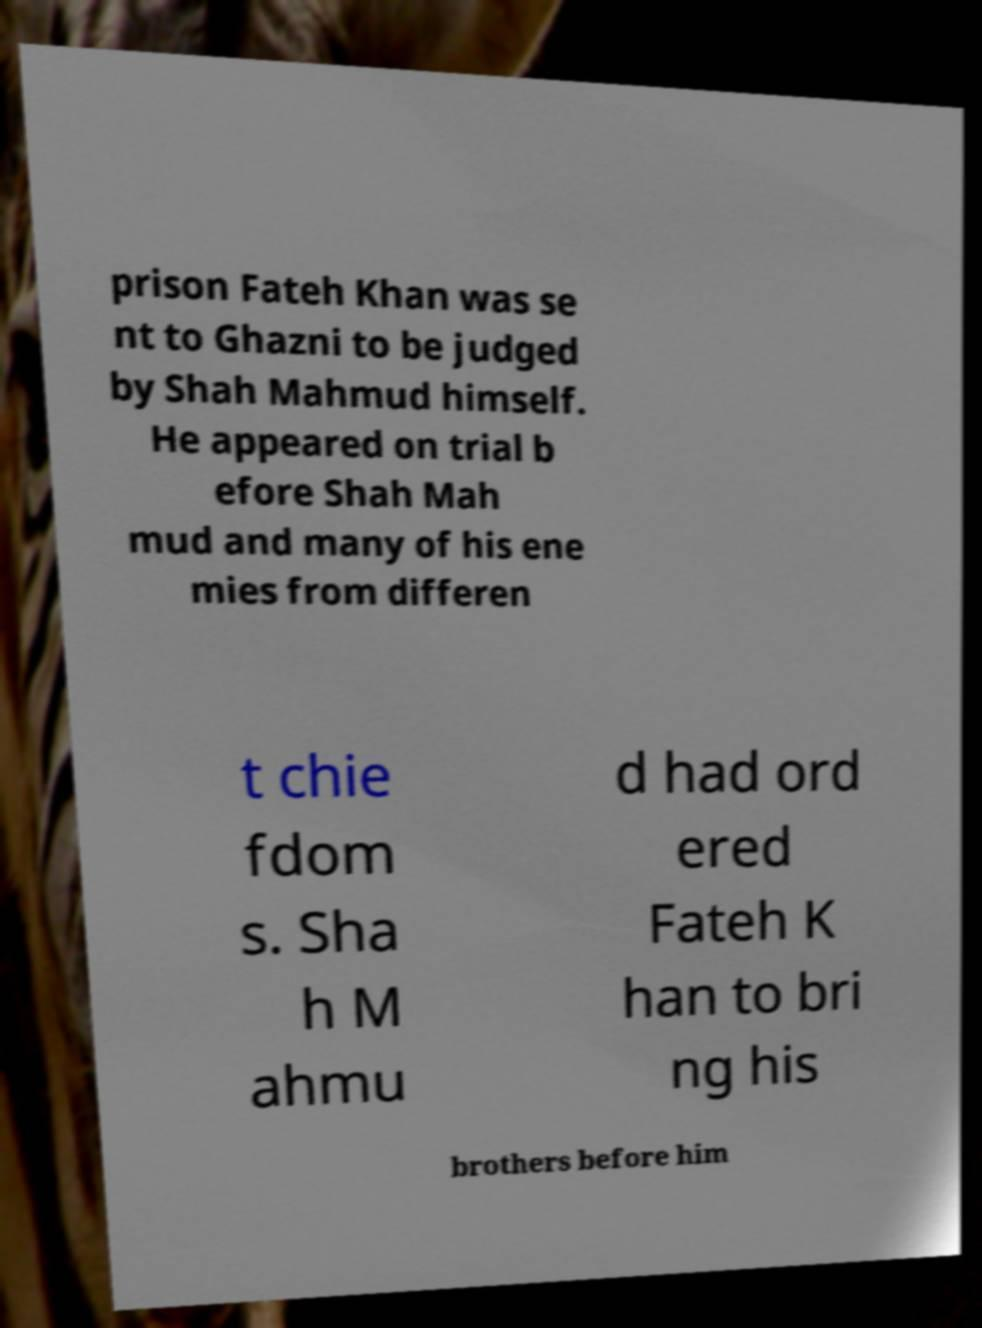There's text embedded in this image that I need extracted. Can you transcribe it verbatim? prison Fateh Khan was se nt to Ghazni to be judged by Shah Mahmud himself. He appeared on trial b efore Shah Mah mud and many of his ene mies from differen t chie fdom s. Sha h M ahmu d had ord ered Fateh K han to bri ng his brothers before him 